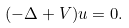<formula> <loc_0><loc_0><loc_500><loc_500>( - \Delta + V ) u = 0 .</formula> 